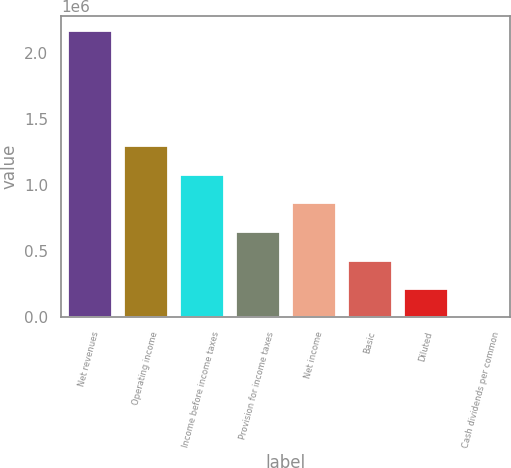Convert chart to OTSL. <chart><loc_0><loc_0><loc_500><loc_500><bar_chart><fcel>Net revenues<fcel>Operating income<fcel>Income before income taxes<fcel>Provision for income taxes<fcel>Net income<fcel>Basic<fcel>Diluted<fcel>Cash dividends per common<nl><fcel>2.16865e+06<fcel>1.30119e+06<fcel>1.08433e+06<fcel>650596<fcel>867461<fcel>433731<fcel>216866<fcel>0.88<nl></chart> 